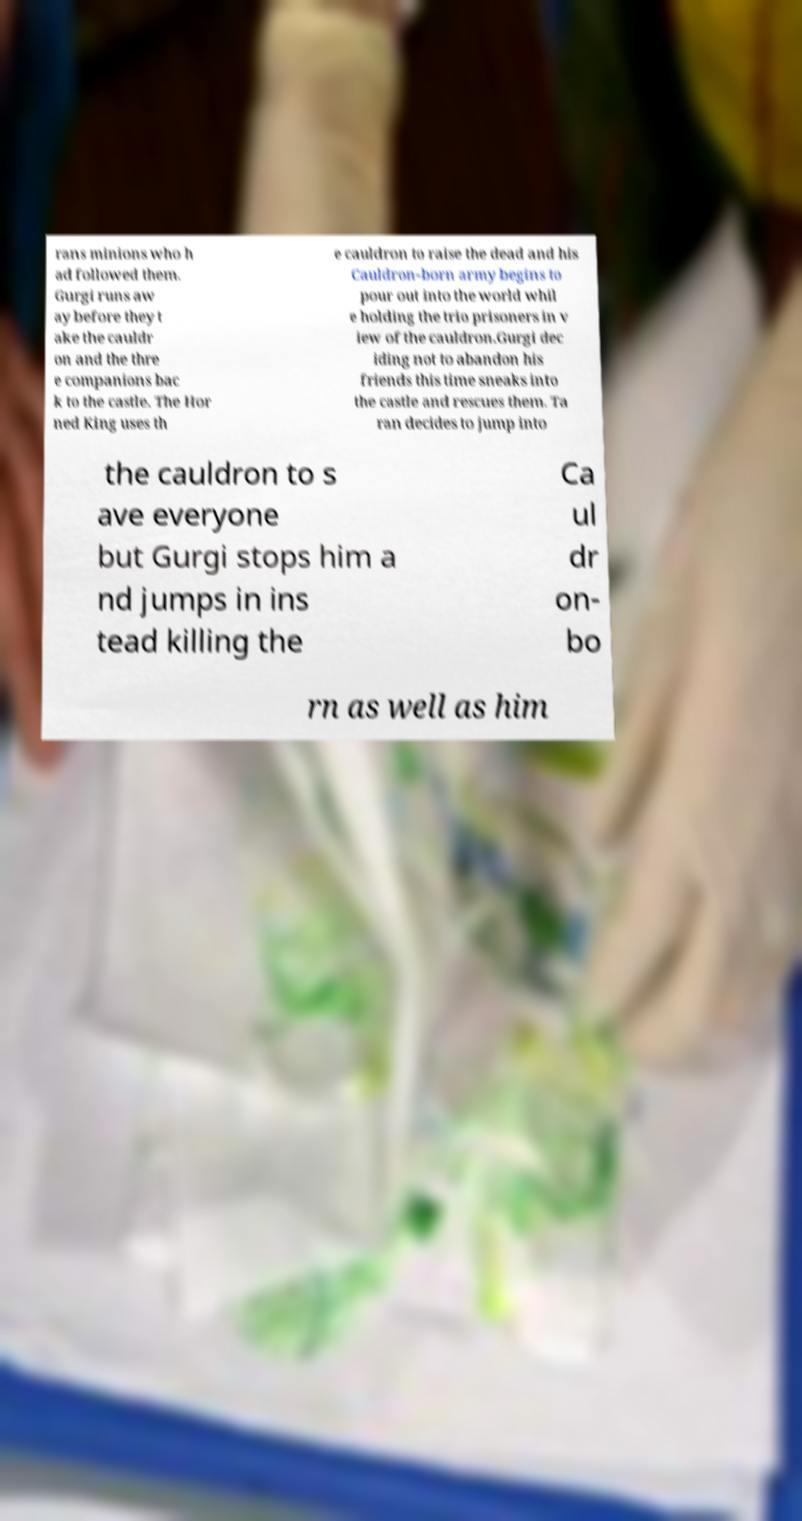There's text embedded in this image that I need extracted. Can you transcribe it verbatim? rans minions who h ad followed them. Gurgi runs aw ay before they t ake the cauldr on and the thre e companions bac k to the castle. The Hor ned King uses th e cauldron to raise the dead and his Cauldron-born army begins to pour out into the world whil e holding the trio prisoners in v iew of the cauldron.Gurgi dec iding not to abandon his friends this time sneaks into the castle and rescues them. Ta ran decides to jump into the cauldron to s ave everyone but Gurgi stops him a nd jumps in ins tead killing the Ca ul dr on- bo rn as well as him 